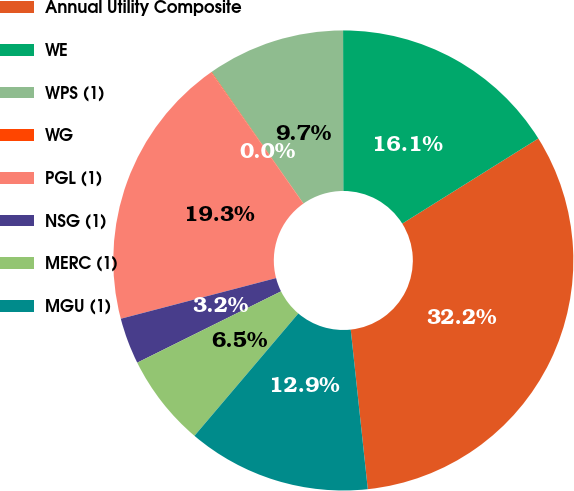<chart> <loc_0><loc_0><loc_500><loc_500><pie_chart><fcel>Annual Utility Composite<fcel>WE<fcel>WPS (1)<fcel>WG<fcel>PGL (1)<fcel>NSG (1)<fcel>MERC (1)<fcel>MGU (1)<nl><fcel>32.2%<fcel>16.12%<fcel>9.69%<fcel>0.04%<fcel>19.33%<fcel>3.25%<fcel>6.47%<fcel>12.9%<nl></chart> 